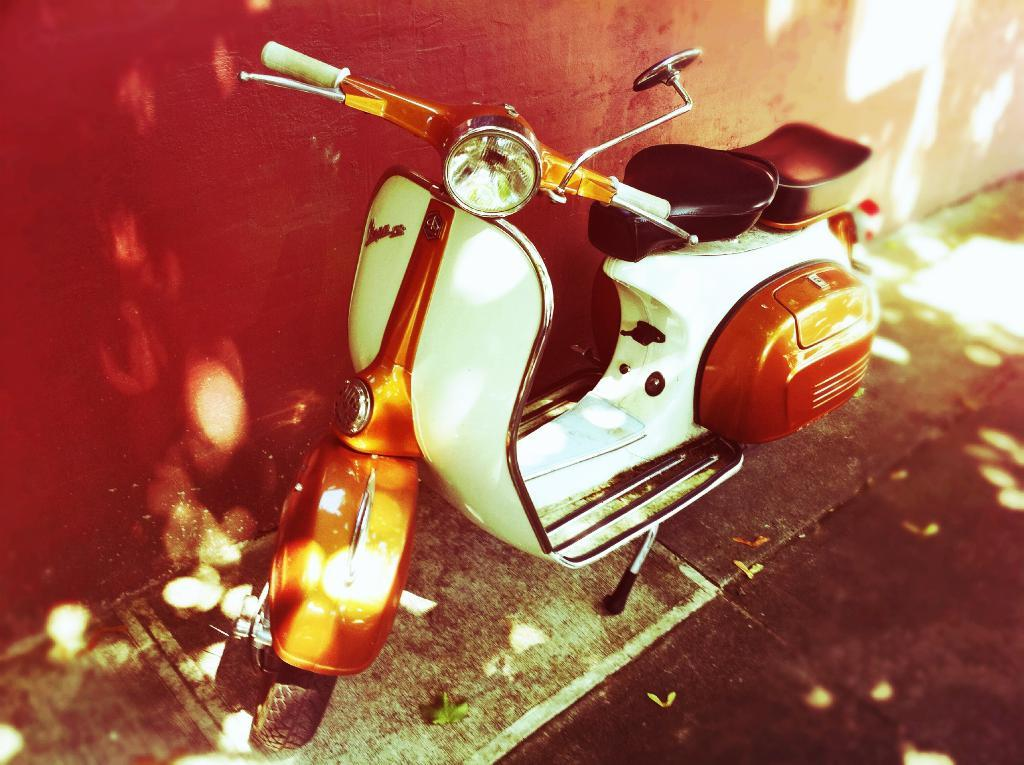What type of vehicle is in the image? There is a Vespa vintage scooter in the image. Where is the scooter located in relation to the wall? The scooter is parked near a red wall. What can be seen on the ground in the image? There are leaves on the surface in the image. How many potatoes are on the scooter in the image? There are no potatoes present in the image; it features a Vespa vintage scooter parked near a red wall with leaves on the ground. 